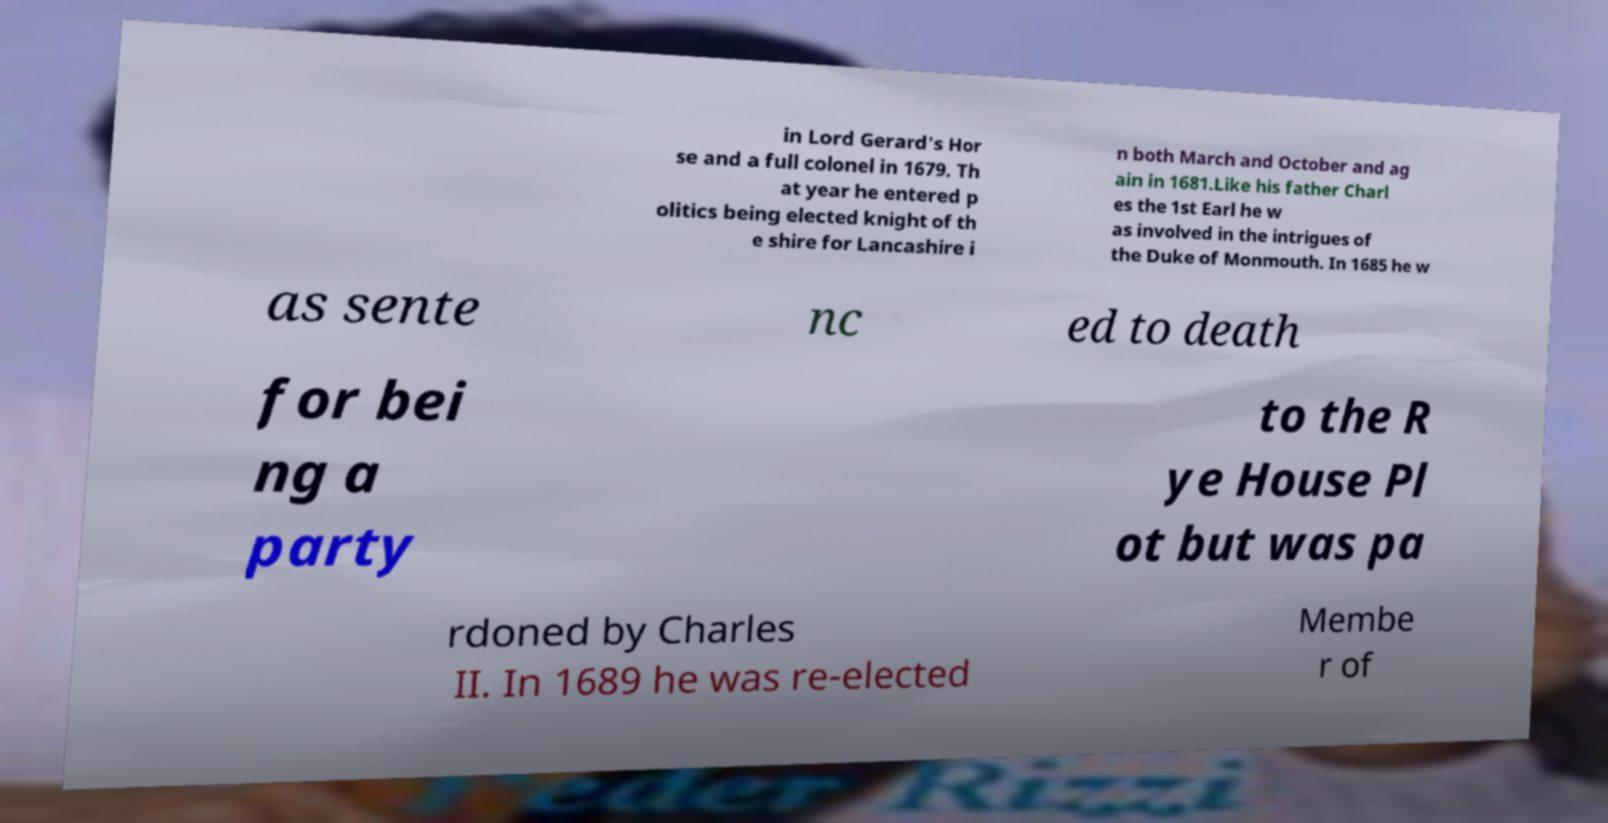Could you assist in decoding the text presented in this image and type it out clearly? in Lord Gerard's Hor se and a full colonel in 1679. Th at year he entered p olitics being elected knight of th e shire for Lancashire i n both March and October and ag ain in 1681.Like his father Charl es the 1st Earl he w as involved in the intrigues of the Duke of Monmouth. In 1685 he w as sente nc ed to death for bei ng a party to the R ye House Pl ot but was pa rdoned by Charles II. In 1689 he was re-elected Membe r of 